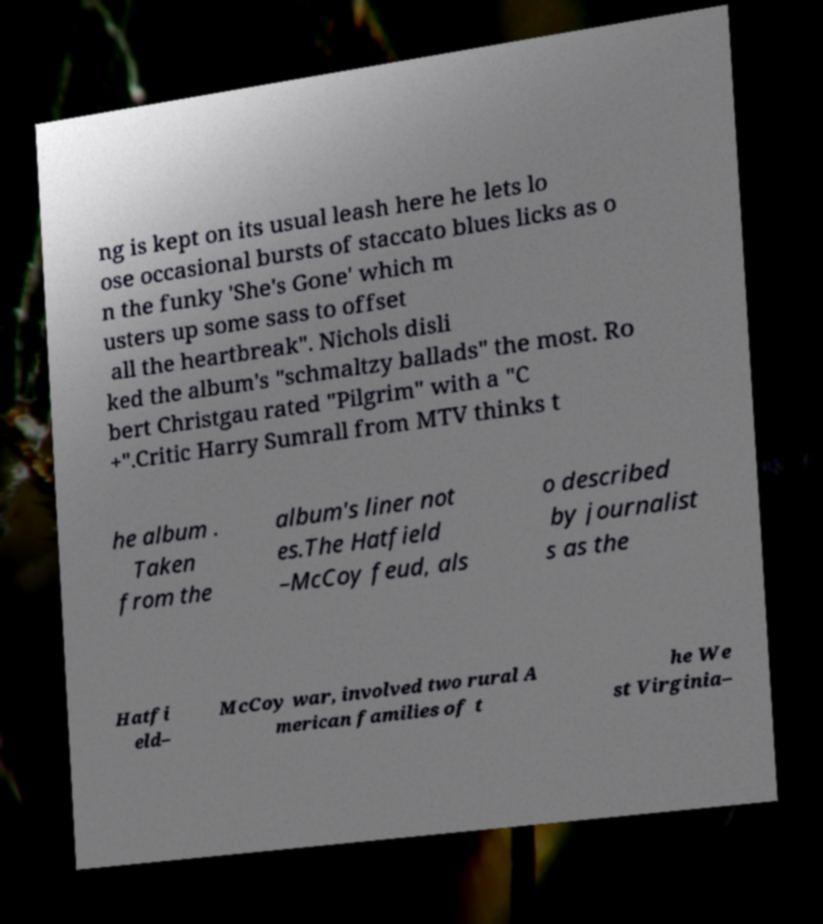Please identify and transcribe the text found in this image. ng is kept on its usual leash here he lets lo ose occasional bursts of staccato blues licks as o n the funky 'She's Gone' which m usters up some sass to offset all the heartbreak". Nichols disli ked the album's "schmaltzy ballads" the most. Ro bert Christgau rated "Pilgrim" with a "C +".Critic Harry Sumrall from MTV thinks t he album . Taken from the album's liner not es.The Hatfield –McCoy feud, als o described by journalist s as the Hatfi eld– McCoy war, involved two rural A merican families of t he We st Virginia– 